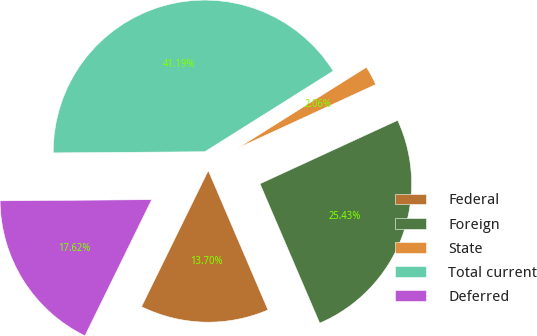Convert chart to OTSL. <chart><loc_0><loc_0><loc_500><loc_500><pie_chart><fcel>Federal<fcel>Foreign<fcel>State<fcel>Total current<fcel>Deferred<nl><fcel>13.7%<fcel>25.43%<fcel>2.06%<fcel>41.19%<fcel>17.62%<nl></chart> 